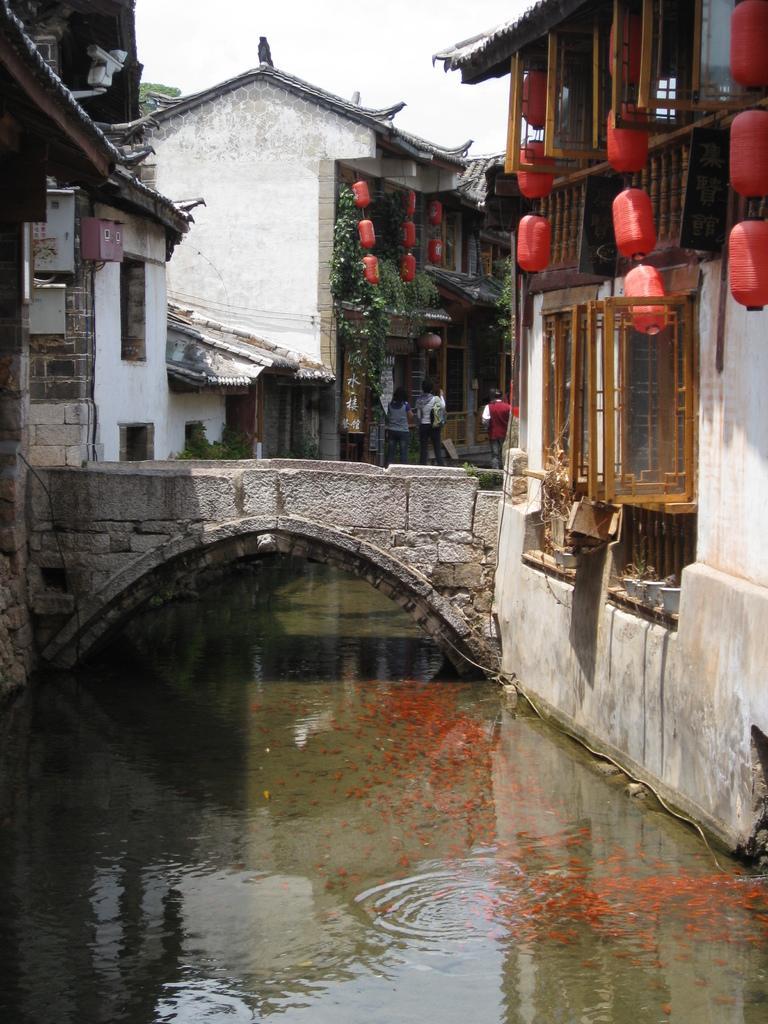Please provide a concise description of this image. In the picture there is a bridge, there are fishes present in the water, there are buildings, there are people present, there is a clear sky. 